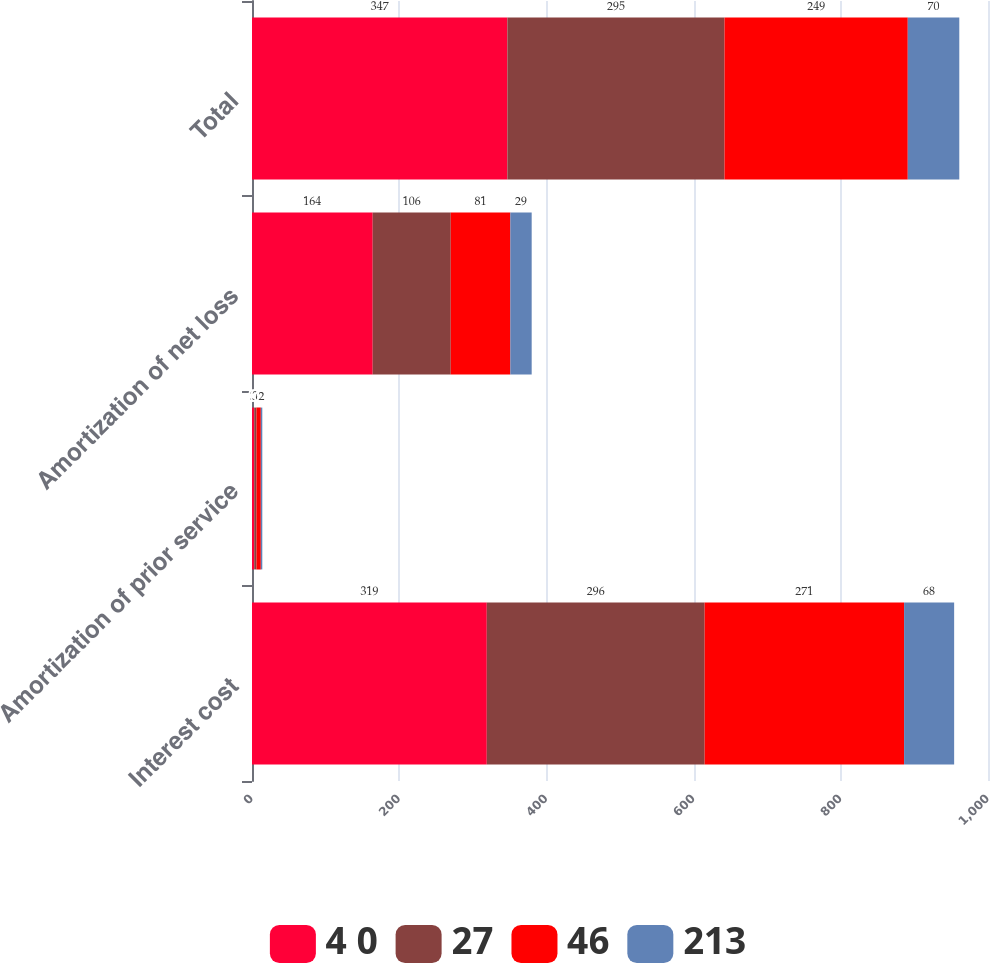Convert chart. <chart><loc_0><loc_0><loc_500><loc_500><stacked_bar_chart><ecel><fcel>Interest cost<fcel>Amortization of prior service<fcel>Amortization of net loss<fcel>Total<nl><fcel>4 0<fcel>319<fcel>3<fcel>164<fcel>347<nl><fcel>27<fcel>296<fcel>3<fcel>106<fcel>295<nl><fcel>46<fcel>271<fcel>6<fcel>81<fcel>249<nl><fcel>213<fcel>68<fcel>2<fcel>29<fcel>70<nl></chart> 